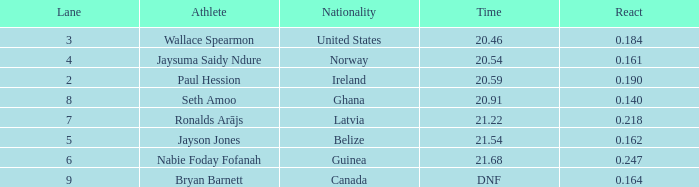164? Bryan Barnett. Can you give me this table as a dict? {'header': ['Lane', 'Athlete', 'Nationality', 'Time', 'React'], 'rows': [['3', 'Wallace Spearmon', 'United States', '20.46', '0.184'], ['4', 'Jaysuma Saidy Ndure', 'Norway', '20.54', '0.161'], ['2', 'Paul Hession', 'Ireland', '20.59', '0.190'], ['8', 'Seth Amoo', 'Ghana', '20.91', '0.140'], ['7', 'Ronalds Arājs', 'Latvia', '21.22', '0.218'], ['5', 'Jayson Jones', 'Belize', '21.54', '0.162'], ['6', 'Nabie Foday Fofanah', 'Guinea', '21.68', '0.247'], ['9', 'Bryan Barnett', 'Canada', 'DNF', '0.164']]} 